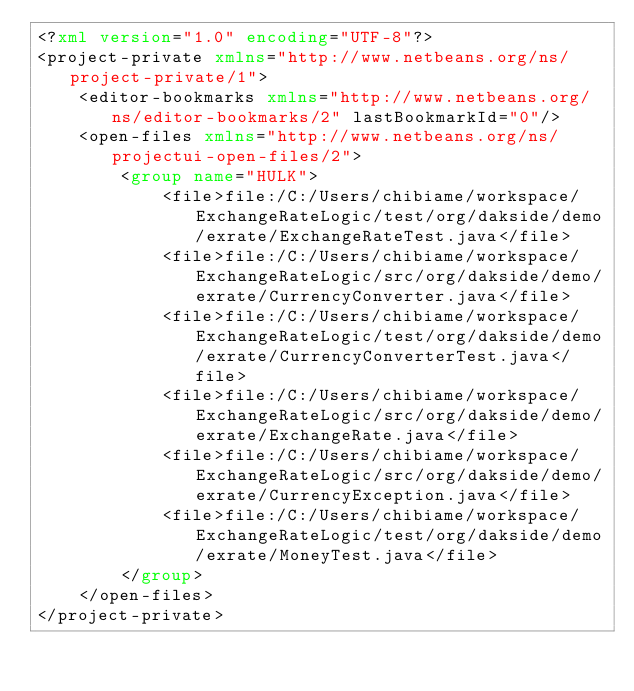Convert code to text. <code><loc_0><loc_0><loc_500><loc_500><_XML_><?xml version="1.0" encoding="UTF-8"?>
<project-private xmlns="http://www.netbeans.org/ns/project-private/1">
    <editor-bookmarks xmlns="http://www.netbeans.org/ns/editor-bookmarks/2" lastBookmarkId="0"/>
    <open-files xmlns="http://www.netbeans.org/ns/projectui-open-files/2">
        <group name="HULK">
            <file>file:/C:/Users/chibiame/workspace/ExchangeRateLogic/test/org/dakside/demo/exrate/ExchangeRateTest.java</file>
            <file>file:/C:/Users/chibiame/workspace/ExchangeRateLogic/src/org/dakside/demo/exrate/CurrencyConverter.java</file>
            <file>file:/C:/Users/chibiame/workspace/ExchangeRateLogic/test/org/dakside/demo/exrate/CurrencyConverterTest.java</file>
            <file>file:/C:/Users/chibiame/workspace/ExchangeRateLogic/src/org/dakside/demo/exrate/ExchangeRate.java</file>
            <file>file:/C:/Users/chibiame/workspace/ExchangeRateLogic/src/org/dakside/demo/exrate/CurrencyException.java</file>
            <file>file:/C:/Users/chibiame/workspace/ExchangeRateLogic/test/org/dakside/demo/exrate/MoneyTest.java</file>
        </group>
    </open-files>
</project-private>
</code> 